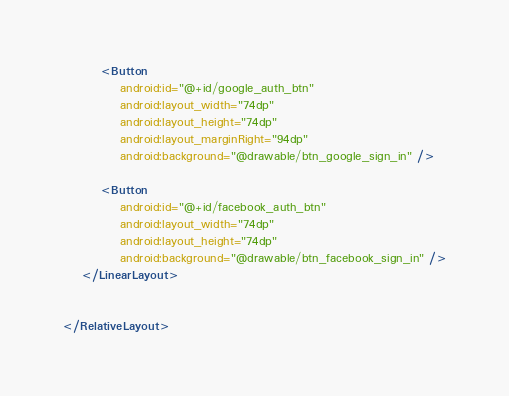Convert code to text. <code><loc_0><loc_0><loc_500><loc_500><_XML_>
        <Button
            android:id="@+id/google_auth_btn"
            android:layout_width="74dp"
            android:layout_height="74dp"
            android:layout_marginRight="94dp"
            android:background="@drawable/btn_google_sign_in" />

        <Button
            android:id="@+id/facebook_auth_btn"
            android:layout_width="74dp"
            android:layout_height="74dp"
            android:background="@drawable/btn_facebook_sign_in" />
    </LinearLayout>


</RelativeLayout></code> 